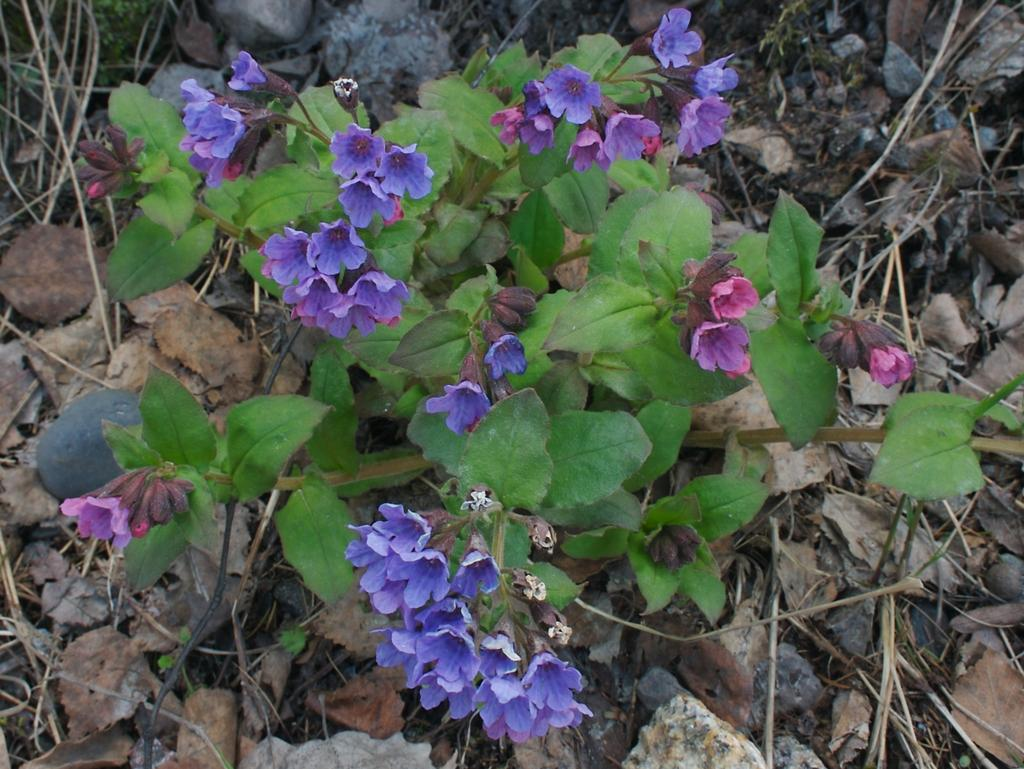What type of plant is visible in the image? There is a plant in the image. What are the plant's features in the image? There are flowers and leaves visible in the image. What type of trouble can be seen in the image? There is no trouble present in the image; it features a plant with flowers and leaves. Can you tell me how many volleyballs are visible in the image? There are no volleyballs present in the image. 